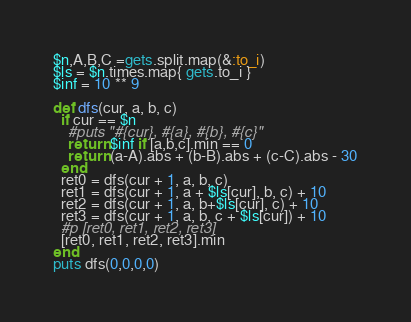Convert code to text. <code><loc_0><loc_0><loc_500><loc_500><_Ruby_>$n,A,B,C =gets.split.map(&:to_i)
$ls = $n.times.map{ gets.to_i }
$inf = 10 ** 9

def dfs(cur, a, b, c)
  if cur == $n
    #puts "#{cur}, #{a}, #{b}, #{c}"
    return $inf if [a,b,c].min == 0
    return (a-A).abs + (b-B).abs + (c-C).abs - 30
  end
  ret0 = dfs(cur + 1, a, b, c)
  ret1 = dfs(cur + 1, a + $ls[cur], b, c) + 10
  ret2 = dfs(cur + 1, a, b+$ls[cur], c) + 10
  ret3 = dfs(cur + 1, a, b, c + $ls[cur]) + 10
  #p [ret0, ret1, ret2, ret3]
  [ret0, ret1, ret2, ret3].min
end
puts dfs(0,0,0,0)</code> 